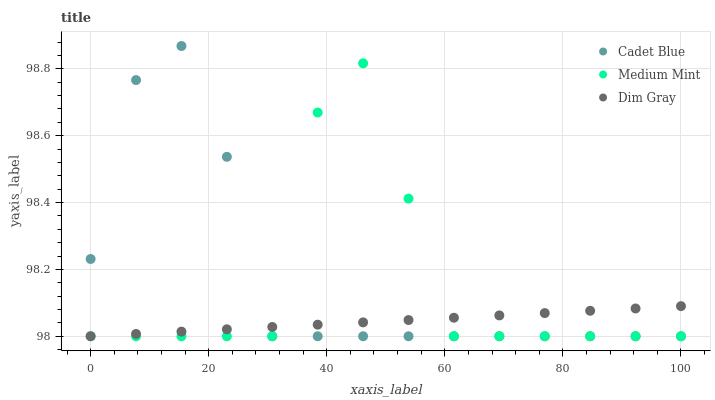Does Dim Gray have the minimum area under the curve?
Answer yes or no. Yes. Does Cadet Blue have the maximum area under the curve?
Answer yes or no. Yes. Does Cadet Blue have the minimum area under the curve?
Answer yes or no. No. Does Dim Gray have the maximum area under the curve?
Answer yes or no. No. Is Dim Gray the smoothest?
Answer yes or no. Yes. Is Medium Mint the roughest?
Answer yes or no. Yes. Is Cadet Blue the smoothest?
Answer yes or no. No. Is Cadet Blue the roughest?
Answer yes or no. No. Does Medium Mint have the lowest value?
Answer yes or no. Yes. Does Cadet Blue have the highest value?
Answer yes or no. Yes. Does Dim Gray have the highest value?
Answer yes or no. No. Does Cadet Blue intersect Medium Mint?
Answer yes or no. Yes. Is Cadet Blue less than Medium Mint?
Answer yes or no. No. Is Cadet Blue greater than Medium Mint?
Answer yes or no. No. 